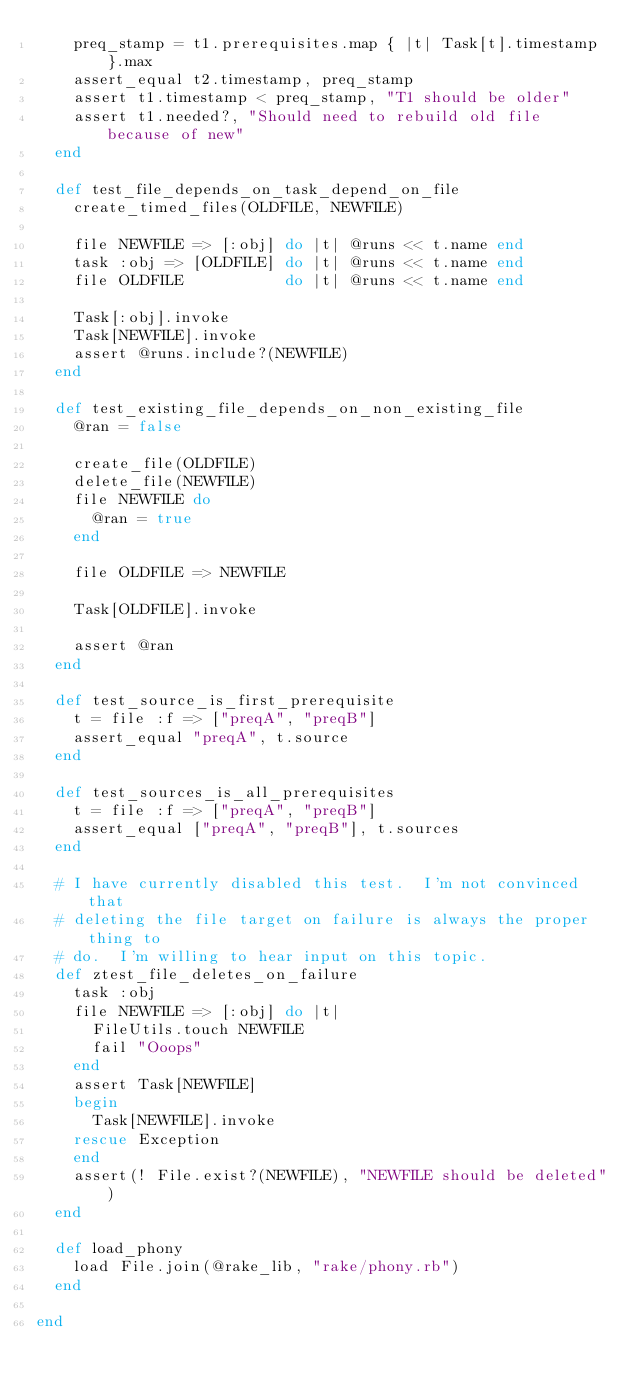Convert code to text. <code><loc_0><loc_0><loc_500><loc_500><_Ruby_>    preq_stamp = t1.prerequisites.map { |t| Task[t].timestamp }.max
    assert_equal t2.timestamp, preq_stamp
    assert t1.timestamp < preq_stamp, "T1 should be older"
    assert t1.needed?, "Should need to rebuild old file because of new"
  end

  def test_file_depends_on_task_depend_on_file
    create_timed_files(OLDFILE, NEWFILE)

    file NEWFILE => [:obj] do |t| @runs << t.name end
    task :obj => [OLDFILE] do |t| @runs << t.name end
    file OLDFILE           do |t| @runs << t.name end

    Task[:obj].invoke
    Task[NEWFILE].invoke
    assert @runs.include?(NEWFILE)
  end

  def test_existing_file_depends_on_non_existing_file
    @ran = false

    create_file(OLDFILE)
    delete_file(NEWFILE)
    file NEWFILE do
      @ran = true
    end

    file OLDFILE => NEWFILE

    Task[OLDFILE].invoke

    assert @ran
  end

  def test_source_is_first_prerequisite
    t = file :f => ["preqA", "preqB"]
    assert_equal "preqA", t.source
  end

  def test_sources_is_all_prerequisites
    t = file :f => ["preqA", "preqB"]
    assert_equal ["preqA", "preqB"], t.sources
  end

  # I have currently disabled this test.  I'm not convinced that
  # deleting the file target on failure is always the proper thing to
  # do.  I'm willing to hear input on this topic.
  def ztest_file_deletes_on_failure
    task :obj
    file NEWFILE => [:obj] do |t|
      FileUtils.touch NEWFILE
      fail "Ooops"
    end
    assert Task[NEWFILE]
    begin
      Task[NEWFILE].invoke
    rescue Exception
    end
    assert(! File.exist?(NEWFILE), "NEWFILE should be deleted")
  end

  def load_phony
    load File.join(@rake_lib, "rake/phony.rb")
  end

end
</code> 